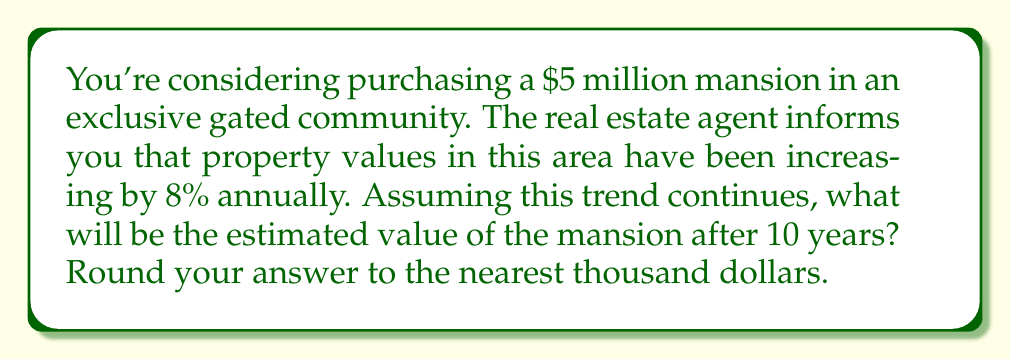Solve this math problem. To solve this problem, we'll use the exponential growth model:

$A = P(1 + r)^t$

Where:
$A$ = Final amount
$P$ = Principal (initial amount)
$r$ = Growth rate (as a decimal)
$t$ = Time period

Given:
$P = \$5,000,000$ (initial value)
$r = 8\% = 0.08$ (annual growth rate)
$t = 10$ years

Let's plug these values into our formula:

$A = 5,000,000(1 + 0.08)^{10}$

Now, let's calculate step-by-step:

1) First, calculate $(1 + 0.08)^{10}$:
   $$(1.08)^{10} = 2.1589250246$$

2) Multiply this by the initial value:
   $$5,000,000 \times 2.1589250246 = 10,794,625.123$$

3) Round to the nearest thousand:
   $$10,794,625.123 \approx 10,795,000$$

Therefore, after 10 years, the estimated value of the mansion will be $10,795,000.
Answer: $10,795,000 